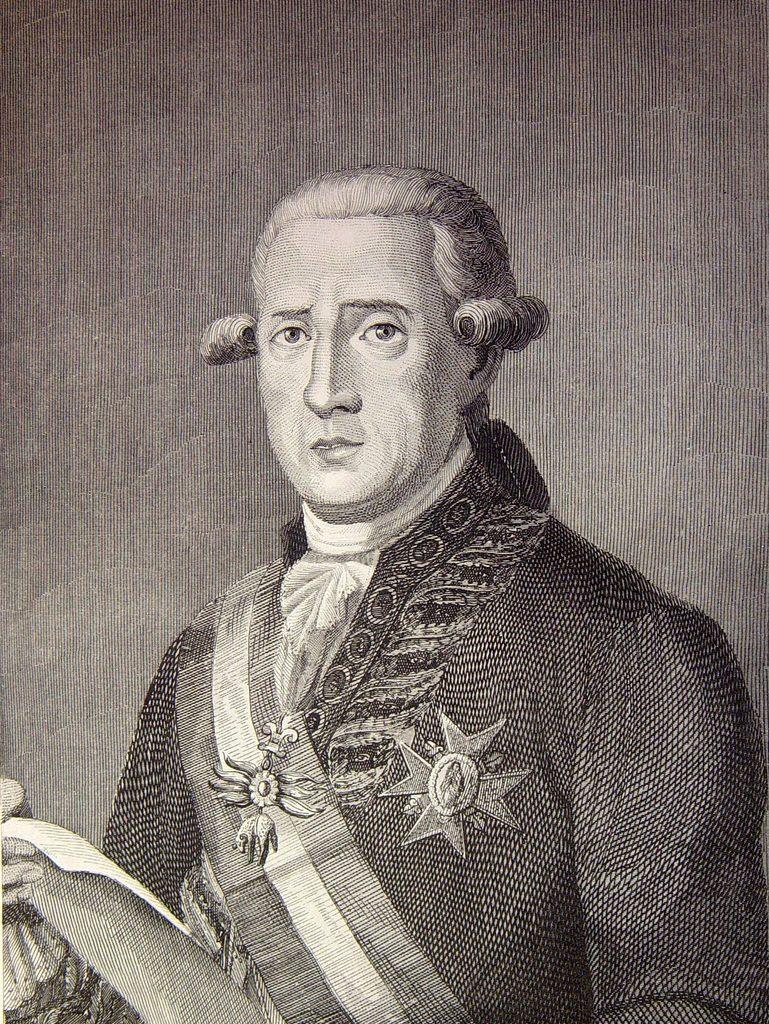In one or two sentences, can you explain what this image depicts? In this picture I can see the painting of a person holding a paper. 